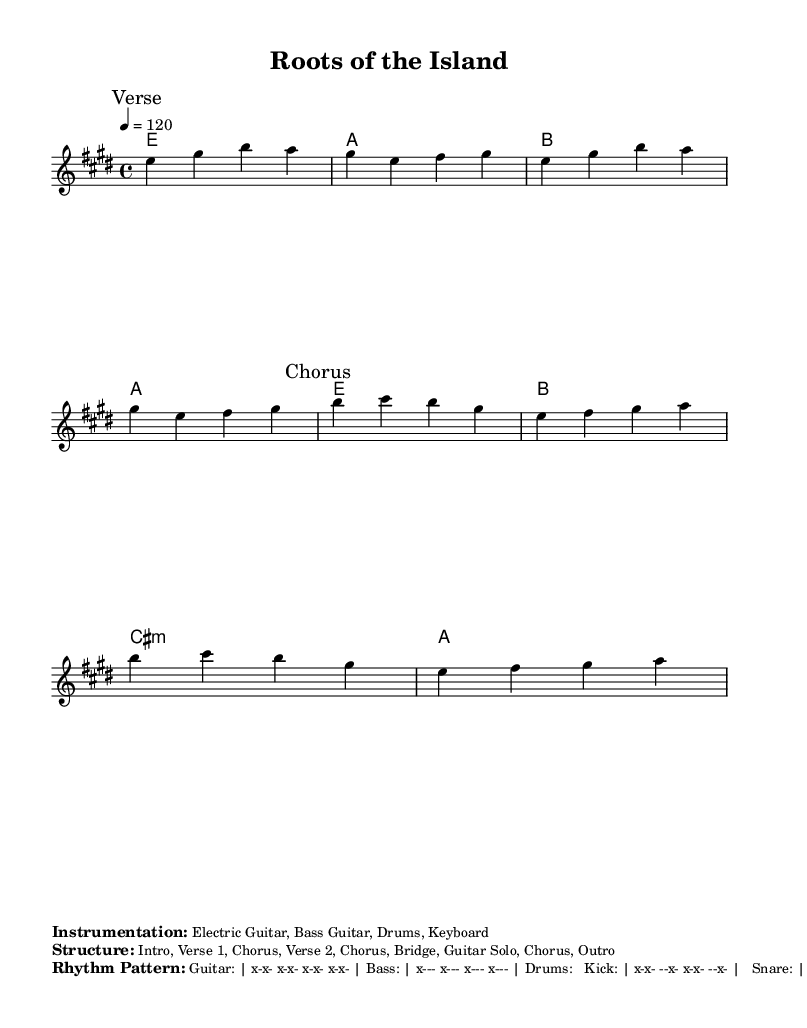What is the key signature of this music? The key signature is E major, which includes four sharps: F#, C#, G#, and D#.
Answer: E major What is the time signature of this music? The time signature shown in the music is 4/4, indicating four beats per measure, with the quarter note receiving one beat.
Answer: 4/4 What is the tempo of this music? The tempo marking is given as 120 beats per minute, which indicates how fast the music should be played.
Answer: 120 How many verses are there in the structure of the song? Analyzing the structure, there is one verse labeled "Verse 1" and one more section indicated as "Verse 2," totaling two verses.
Answer: 2 What instruments are used in this piece? The instrumentation mentioned is Electric Guitar, Bass Guitar, Drums, and Keyboard; these are common instruments in rock music.
Answer: Electric Guitar, Bass Guitar, Drums, Keyboard What lyrical theme is reflected in the chorus? The chorus reflects a theme of cultural identity and heritage, expressing deep roots in the land's history and struggles.
Answer: Cultural identity and heritage 